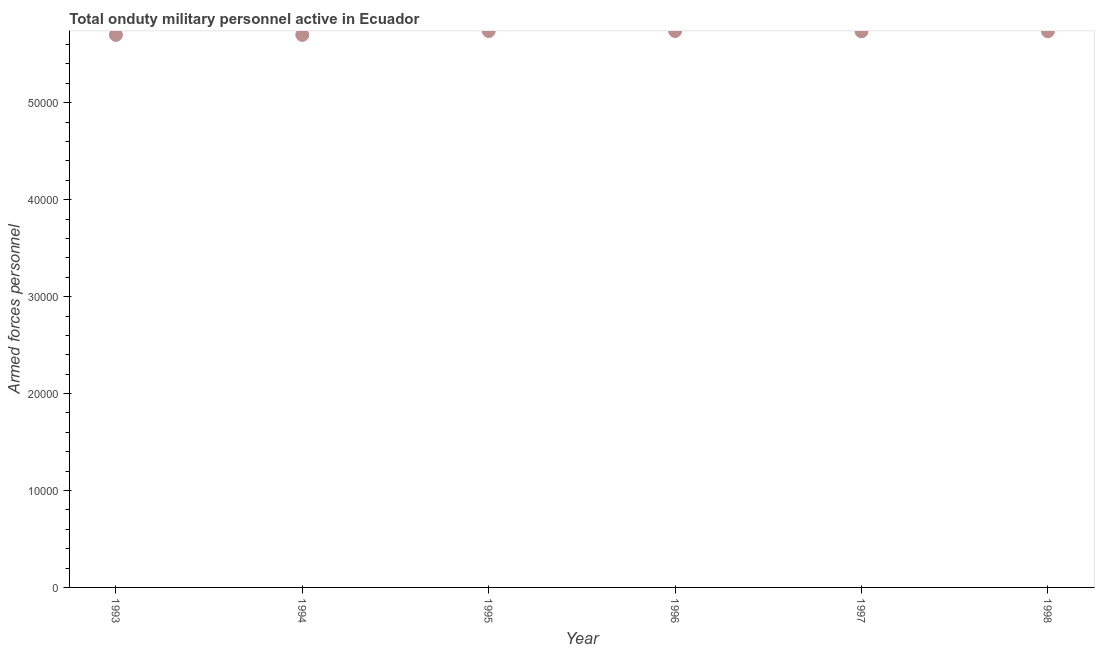What is the number of armed forces personnel in 1995?
Your response must be concise. 5.74e+04. Across all years, what is the maximum number of armed forces personnel?
Your response must be concise. 5.74e+04. Across all years, what is the minimum number of armed forces personnel?
Provide a short and direct response. 5.70e+04. In which year was the number of armed forces personnel maximum?
Ensure brevity in your answer.  1995. What is the sum of the number of armed forces personnel?
Offer a very short reply. 3.44e+05. What is the difference between the number of armed forces personnel in 1993 and 1995?
Keep it short and to the point. -400. What is the average number of armed forces personnel per year?
Provide a succinct answer. 5.73e+04. What is the median number of armed forces personnel?
Provide a succinct answer. 5.74e+04. In how many years, is the number of armed forces personnel greater than 16000 ?
Provide a succinct answer. 6. Do a majority of the years between 1998 and 1994 (inclusive) have number of armed forces personnel greater than 12000 ?
Provide a short and direct response. Yes. What is the ratio of the number of armed forces personnel in 1994 to that in 1998?
Your response must be concise. 0.99. Is the difference between the number of armed forces personnel in 1996 and 1997 greater than the difference between any two years?
Keep it short and to the point. No. Is the sum of the number of armed forces personnel in 1994 and 1995 greater than the maximum number of armed forces personnel across all years?
Make the answer very short. Yes. What is the difference between the highest and the lowest number of armed forces personnel?
Your response must be concise. 400. How many years are there in the graph?
Provide a short and direct response. 6. What is the difference between two consecutive major ticks on the Y-axis?
Provide a succinct answer. 10000. Does the graph contain any zero values?
Offer a very short reply. No. Does the graph contain grids?
Offer a terse response. No. What is the title of the graph?
Your answer should be very brief. Total onduty military personnel active in Ecuador. What is the label or title of the Y-axis?
Your response must be concise. Armed forces personnel. What is the Armed forces personnel in 1993?
Offer a terse response. 5.70e+04. What is the Armed forces personnel in 1994?
Provide a short and direct response. 5.70e+04. What is the Armed forces personnel in 1995?
Provide a succinct answer. 5.74e+04. What is the Armed forces personnel in 1996?
Your response must be concise. 5.74e+04. What is the Armed forces personnel in 1997?
Your response must be concise. 5.74e+04. What is the Armed forces personnel in 1998?
Provide a succinct answer. 5.74e+04. What is the difference between the Armed forces personnel in 1993 and 1995?
Your response must be concise. -400. What is the difference between the Armed forces personnel in 1993 and 1996?
Offer a terse response. -400. What is the difference between the Armed forces personnel in 1993 and 1997?
Ensure brevity in your answer.  -370. What is the difference between the Armed forces personnel in 1993 and 1998?
Your answer should be very brief. -370. What is the difference between the Armed forces personnel in 1994 and 1995?
Provide a short and direct response. -400. What is the difference between the Armed forces personnel in 1994 and 1996?
Ensure brevity in your answer.  -400. What is the difference between the Armed forces personnel in 1994 and 1997?
Your response must be concise. -370. What is the difference between the Armed forces personnel in 1994 and 1998?
Your response must be concise. -370. What is the difference between the Armed forces personnel in 1995 and 1998?
Provide a succinct answer. 30. What is the difference between the Armed forces personnel in 1996 and 1997?
Provide a short and direct response. 30. What is the difference between the Armed forces personnel in 1996 and 1998?
Offer a very short reply. 30. What is the ratio of the Armed forces personnel in 1993 to that in 1997?
Ensure brevity in your answer.  0.99. What is the ratio of the Armed forces personnel in 1993 to that in 1998?
Provide a short and direct response. 0.99. What is the ratio of the Armed forces personnel in 1994 to that in 1997?
Keep it short and to the point. 0.99. What is the ratio of the Armed forces personnel in 1995 to that in 1997?
Your answer should be compact. 1. What is the ratio of the Armed forces personnel in 1995 to that in 1998?
Your answer should be compact. 1. What is the ratio of the Armed forces personnel in 1996 to that in 1997?
Your response must be concise. 1. What is the ratio of the Armed forces personnel in 1996 to that in 1998?
Ensure brevity in your answer.  1. What is the ratio of the Armed forces personnel in 1997 to that in 1998?
Offer a terse response. 1. 